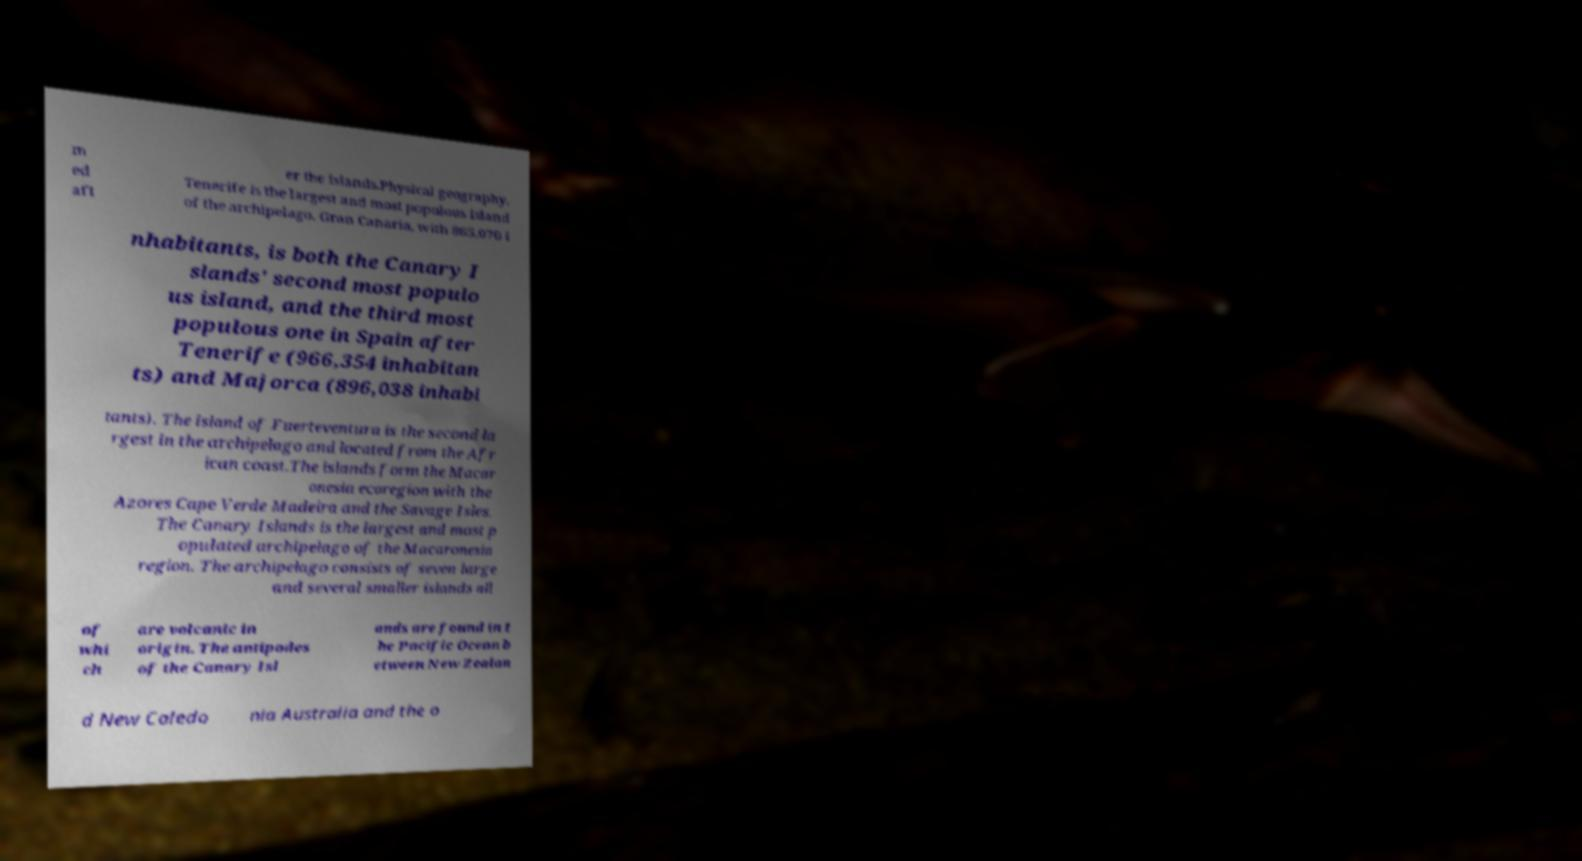Could you extract and type out the text from this image? m ed aft er the islands.Physical geography. Tenerife is the largest and most populous island of the archipelago. Gran Canaria, with 865,070 i nhabitants, is both the Canary I slands' second most populo us island, and the third most populous one in Spain after Tenerife (966,354 inhabitan ts) and Majorca (896,038 inhabi tants). The island of Fuerteventura is the second la rgest in the archipelago and located from the Afr ican coast.The islands form the Macar onesia ecoregion with the Azores Cape Verde Madeira and the Savage Isles. The Canary Islands is the largest and most p opulated archipelago of the Macaronesia region. The archipelago consists of seven large and several smaller islands all of whi ch are volcanic in origin. The antipodes of the Canary Isl ands are found in t he Pacific Ocean b etween New Zealan d New Caledo nia Australia and the o 